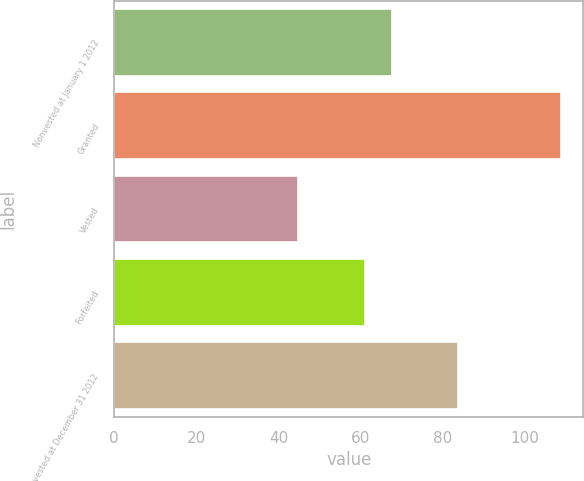Convert chart to OTSL. <chart><loc_0><loc_0><loc_500><loc_500><bar_chart><fcel>Nonvested at January 1 2012<fcel>Granted<fcel>Vested<fcel>Forfeited<fcel>Nonvested at December 31 2012<nl><fcel>67.57<fcel>108.76<fcel>44.7<fcel>61.16<fcel>83.8<nl></chart> 